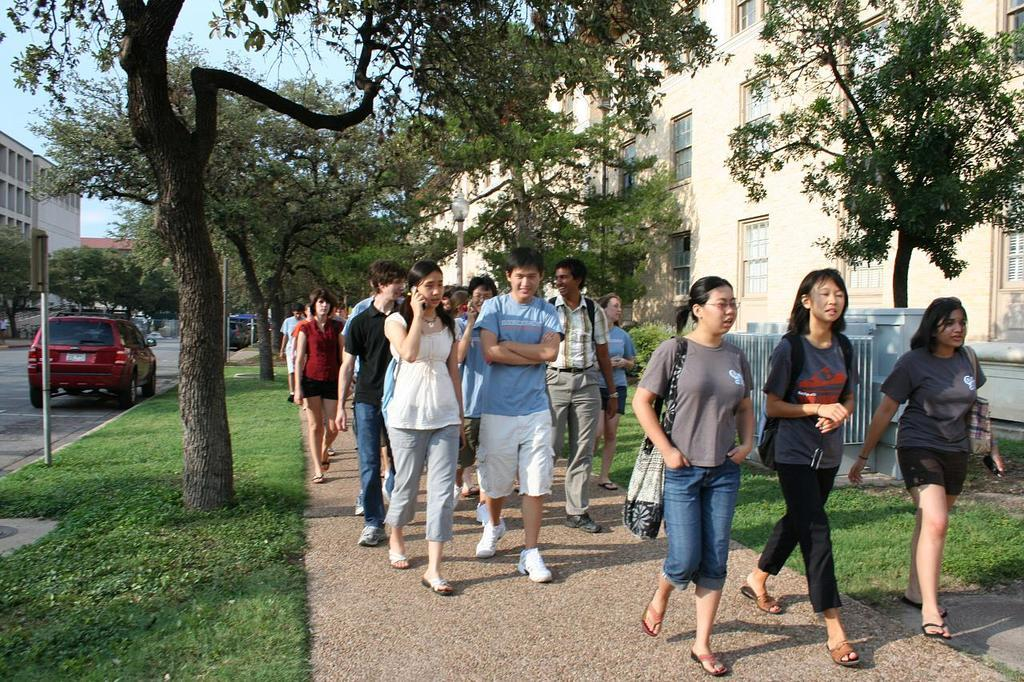What is happening in the image? There is a group of people in the image, and they are walking on a pathway. What can be seen in the background of the image? There are trees and buildings visible in the image. What else is present in the image? There are vehicles on the road in the image. What type of dinner is being served at the home in the image? There is no home or dinner present in the image; it features a group of people walking on a pathway with trees, buildings, and vehicles in the background. Can you tell me how many dogs are visible in the image? There are no dogs present in the image. 